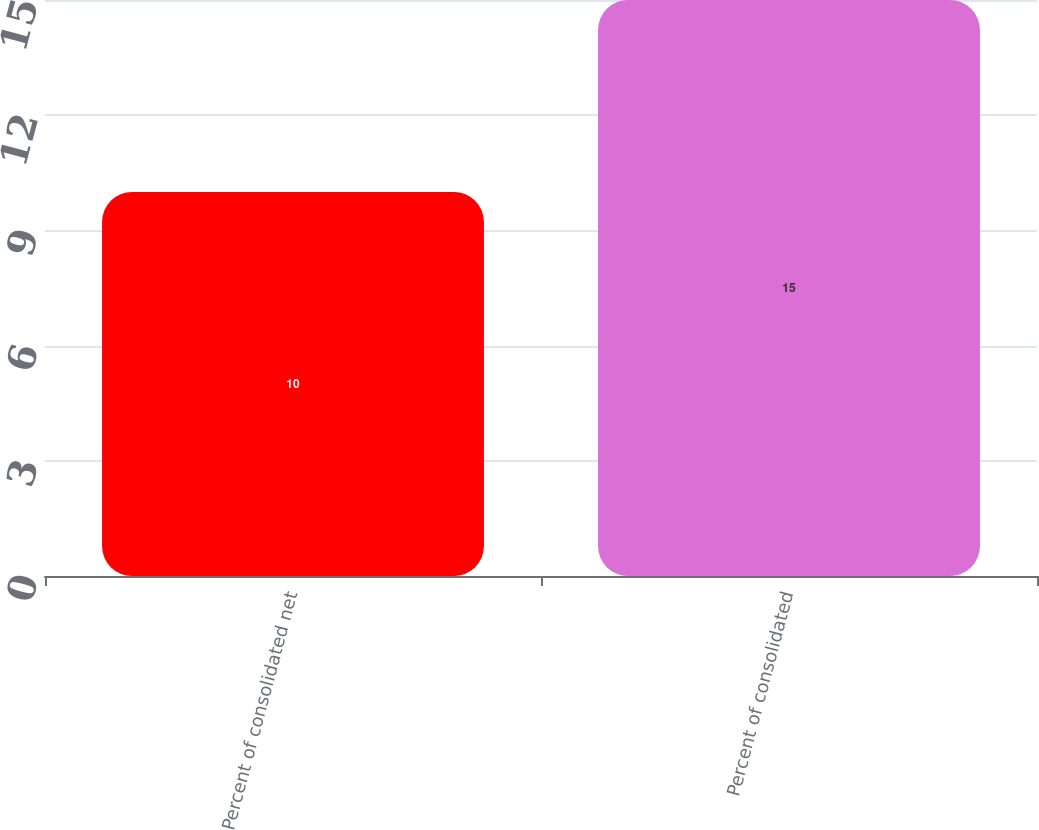<chart> <loc_0><loc_0><loc_500><loc_500><bar_chart><fcel>Percent of consolidated net<fcel>Percent of consolidated<nl><fcel>10<fcel>15<nl></chart> 